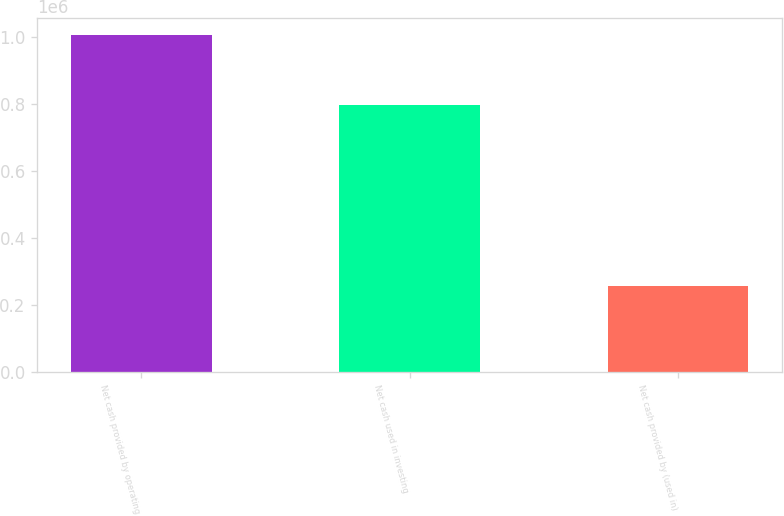Convert chart to OTSL. <chart><loc_0><loc_0><loc_500><loc_500><bar_chart><fcel>Net cash provided by operating<fcel>Net cash used in investing<fcel>Net cash provided by (used in)<nl><fcel>1.00508e+06<fcel>795058<fcel>257879<nl></chart> 